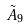Convert formula to latex. <formula><loc_0><loc_0><loc_500><loc_500>\tilde { A } _ { 9 }</formula> 